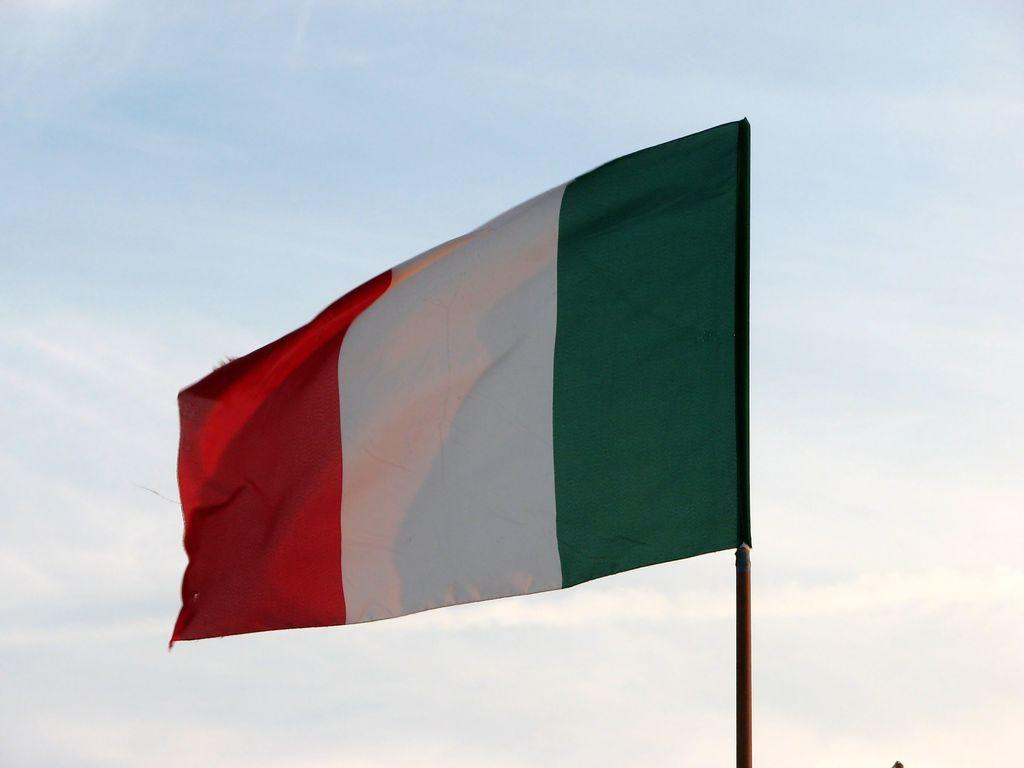What can be seen flying or waving in the image? There is a flag in the image. What is visible in the sky in the image? There are clouds visible in the sky. What type of cork can be seen floating in the image? There is no cork present in the image. Is there a tent visible in the image? No, there is no tent present in the image. 